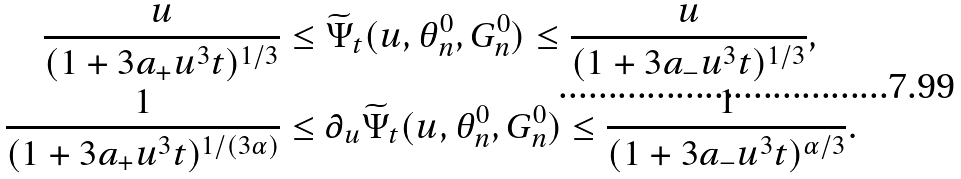Convert formula to latex. <formula><loc_0><loc_0><loc_500><loc_500>\frac { u } { ( 1 + 3 a _ { + } u ^ { 3 } t ) ^ { 1 / 3 } } & \leq \widetilde { \Psi } _ { t } ( u , \theta _ { n } ^ { 0 } , G _ { n } ^ { 0 } ) \leq \frac { u } { ( 1 + 3 a _ { - } u ^ { 3 } t ) ^ { 1 / 3 } } , \\ \frac { 1 } { ( 1 + 3 a _ { + } u ^ { 3 } t ) ^ { 1 / ( 3 \alpha ) } } & \leq \partial _ { u } \widetilde { \Psi } _ { t } ( u , \theta _ { n } ^ { 0 } , G _ { n } ^ { 0 } ) \leq \frac { 1 } { ( 1 + 3 a _ { - } u ^ { 3 } t ) ^ { \alpha / 3 } } .</formula> 